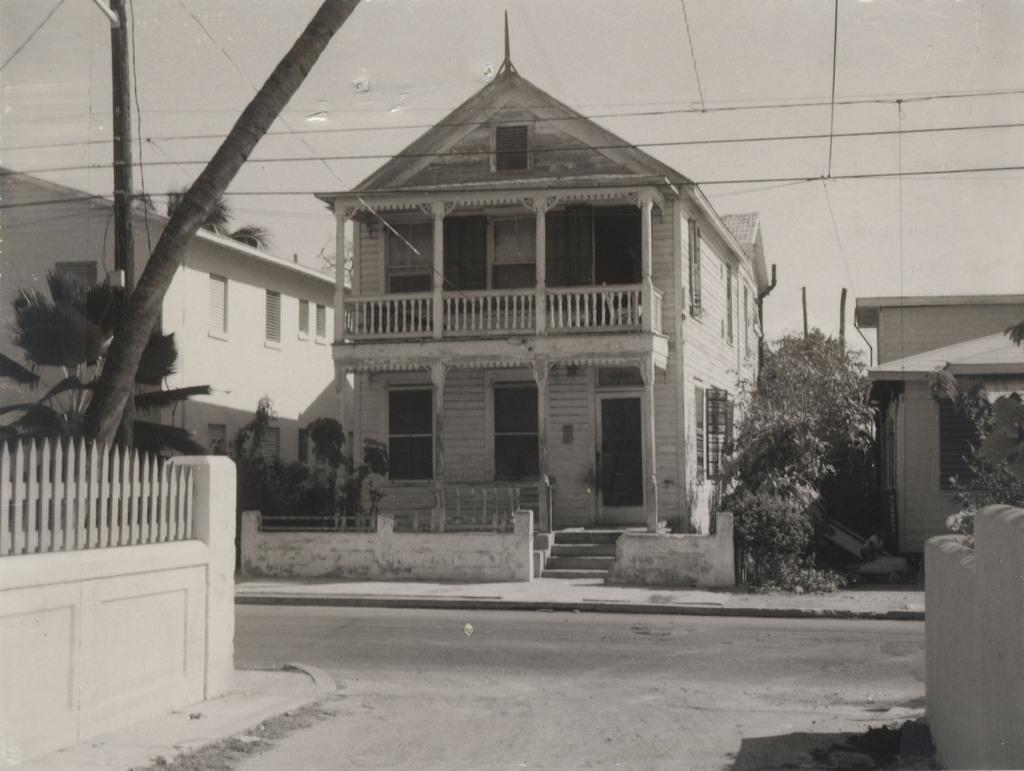In one or two sentences, can you explain what this image depicts? In the center of the image there is a building. On the left side there is a building, tree and a wall. On the right side there is building. At the bottom there is a road. In the background we can see sky. 